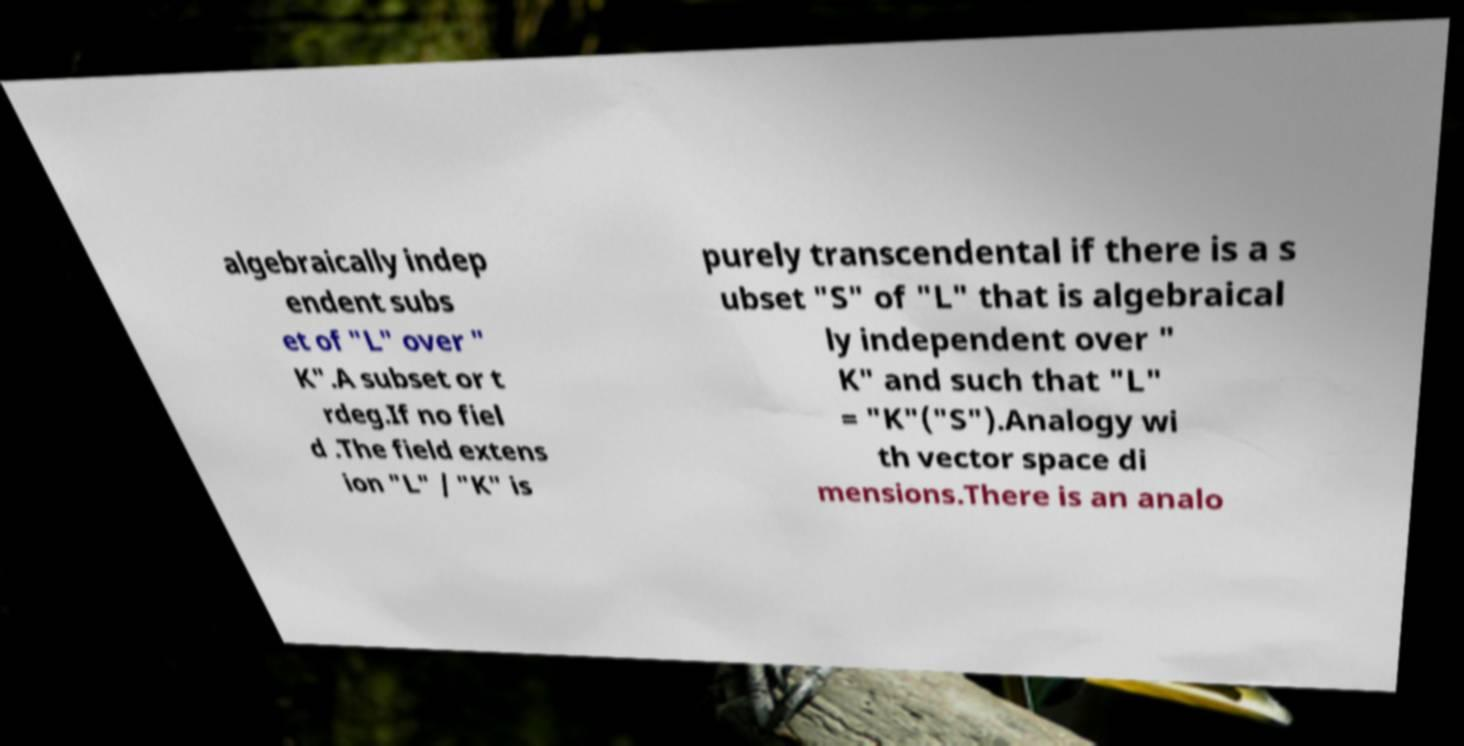For documentation purposes, I need the text within this image transcribed. Could you provide that? algebraically indep endent subs et of "L" over " K".A subset or t rdeg.If no fiel d .The field extens ion "L" / "K" is purely transcendental if there is a s ubset "S" of "L" that is algebraical ly independent over " K" and such that "L" = "K"("S").Analogy wi th vector space di mensions.There is an analo 